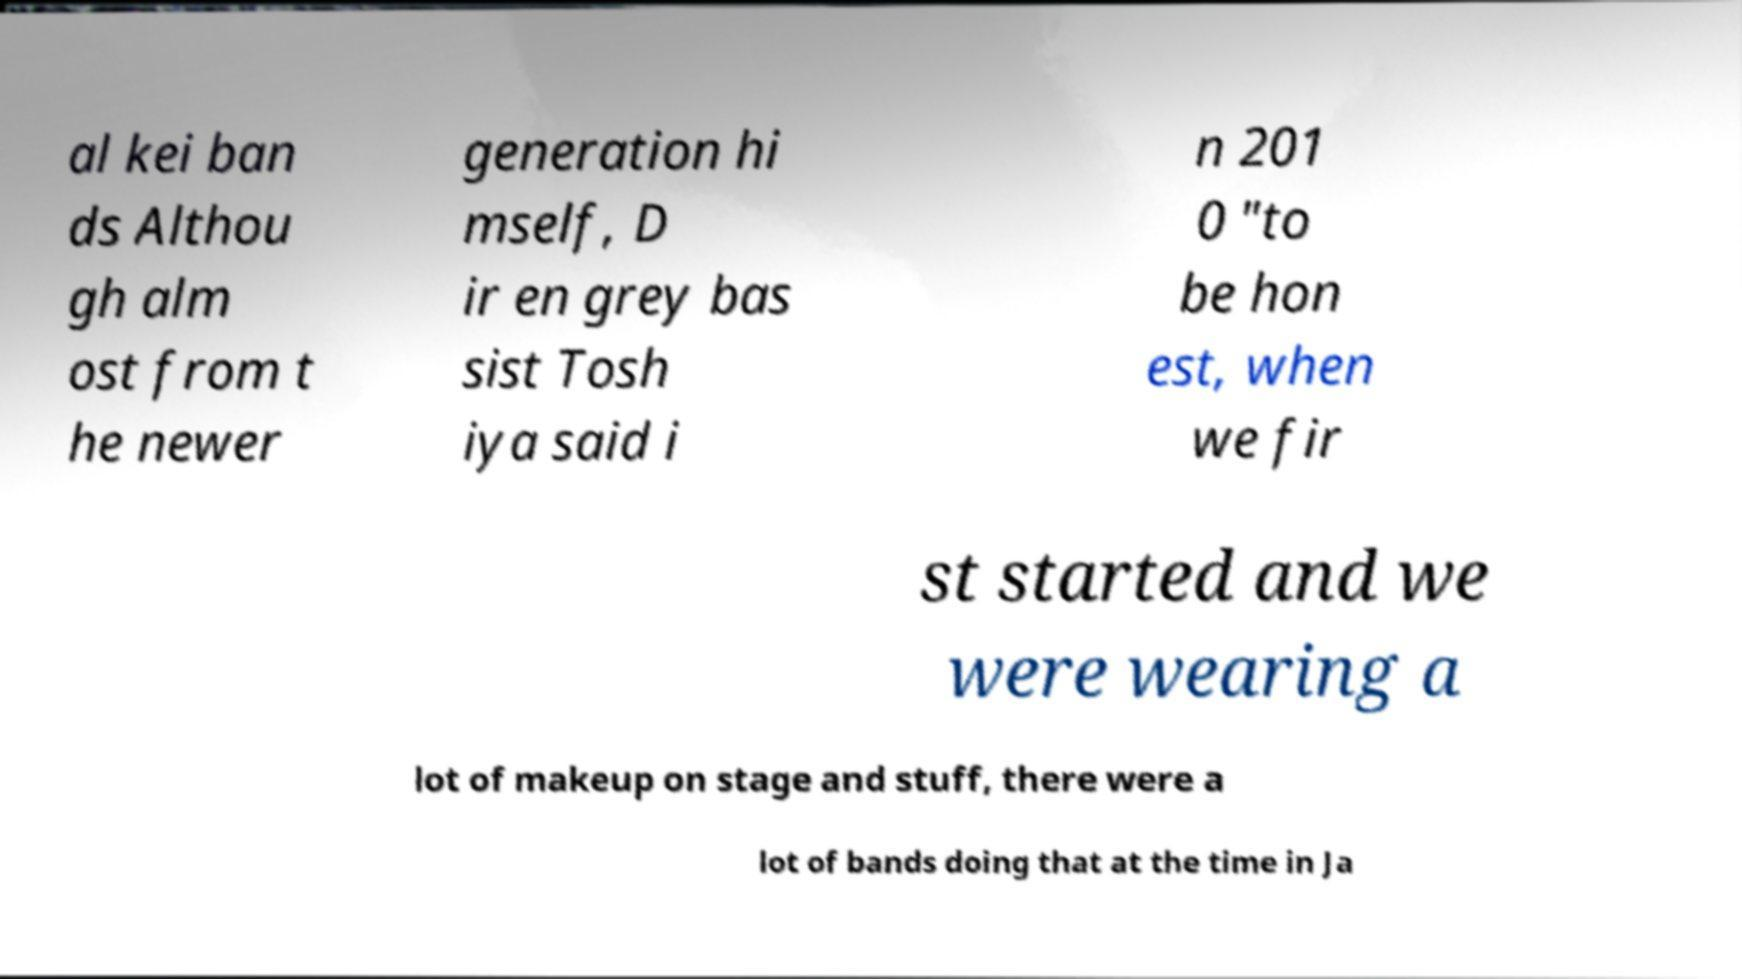Can you read and provide the text displayed in the image?This photo seems to have some interesting text. Can you extract and type it out for me? al kei ban ds Althou gh alm ost from t he newer generation hi mself, D ir en grey bas sist Tosh iya said i n 201 0 "to be hon est, when we fir st started and we were wearing a lot of makeup on stage and stuff, there were a lot of bands doing that at the time in Ja 